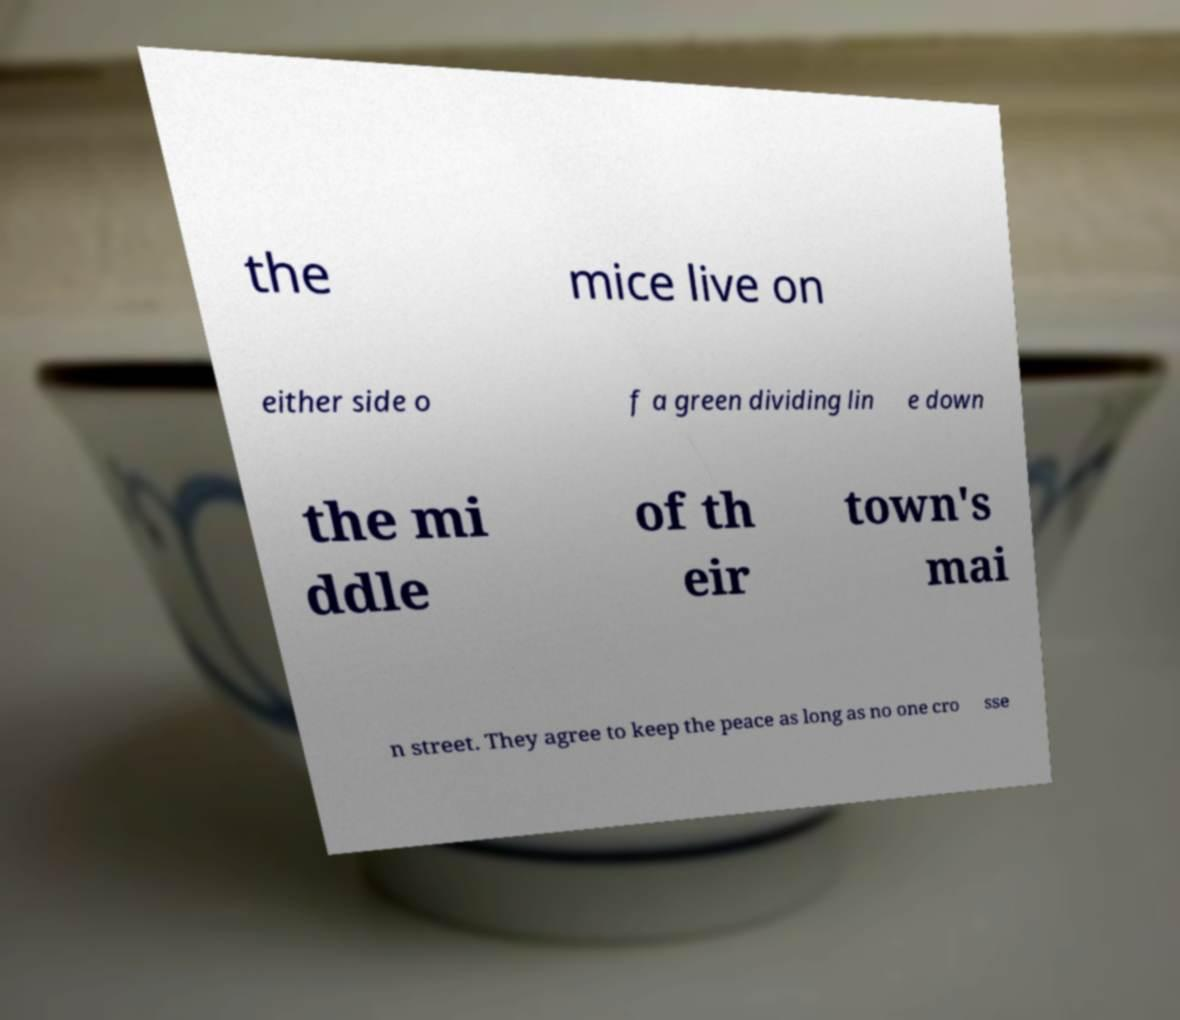Please identify and transcribe the text found in this image. the mice live on either side o f a green dividing lin e down the mi ddle of th eir town's mai n street. They agree to keep the peace as long as no one cro sse 